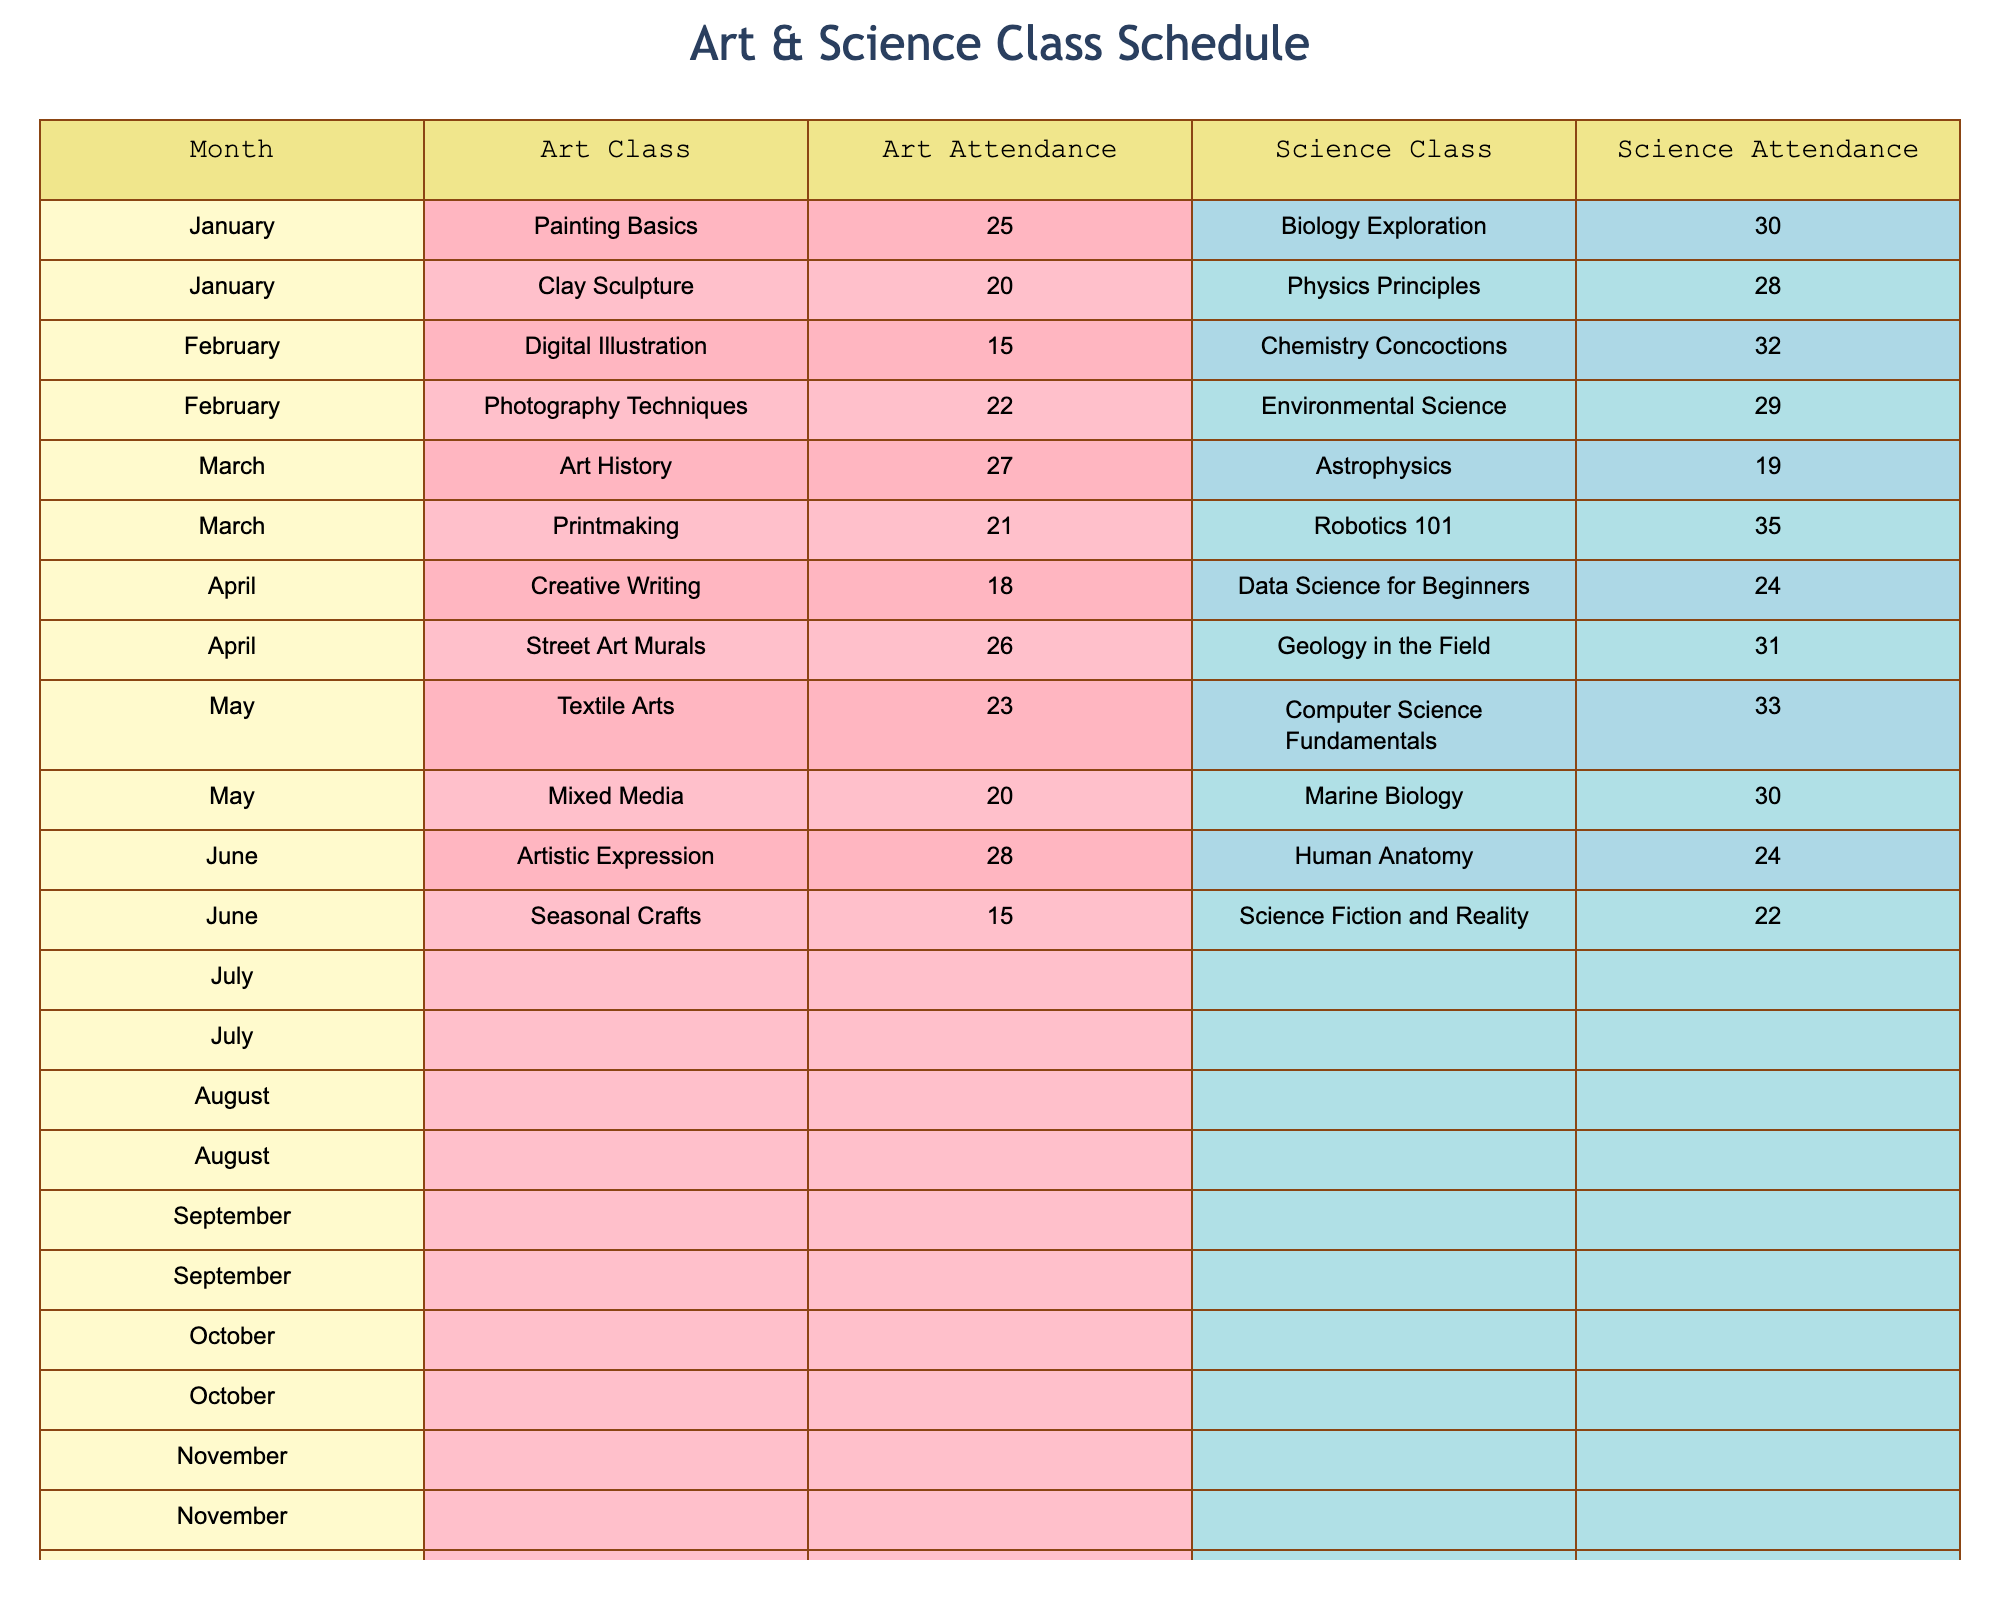What is the attendance count for the Painting Basics class in January? The table indicates that for January, under the Art class type, the class name Painting Basics has an attendance count of 25.
Answer: 25 Which science class had the highest attendance in June? In June, the table shows that the Robotics 101 class had the highest attendance count of 35 compared to other science classes listed for the month.
Answer: 35 What is the average attendance for Art classes from January to June? To find the average attendance for the Art classes from January to June: (25 + 20 + 15 + 22 + 27 + 21) = 130. There are 6 classes, so the average is 130/6 = approximately 21.67.
Answer: 21.67 Did more students attend the Biology Exploration class or the Physics Principles class? Looking at the table, Biology Exploration has an attendance count of 30, while Physics Principles has 28. Since 30 is greater than 28, more students attended the Biology Exploration class.
Answer: Yes In which month did the lowest attendance occur for Art classes, and what was the count? The table shows that in March, the Digital Illustration class had the lowest attendance among Art classes, with a count of 15.
Answer: March, 15 How many students attended all Science classes in the month of August combined? In August, the attendance counts for the Science classes are 31 (Geology in the Field). Since there's only one science class listed for this month, the total attendance is simply 31.
Answer: 31 What was the difference in attendance between the highest and lowest registered science classes in December? In December, Science Fiction and Reality had an attendance of 22, and there are no other science classes listed for that month, hence no difference can be calculated.
Answer: N/A Which month had the most students attending Art classes, and how many attended? By reviewing the table, November had the highest attendance for Art classes, recording 28 attendees for Artistic Expression.
Answer: November, 28 How many students attended both the Clay Sculpture and the Environmental Science classes? From the table, Clay Sculpture had 20 attendees, and Environmental Science had 29 attendees. Therefore, the total number who attended both is 20 + 29 = 49.
Answer: 49 